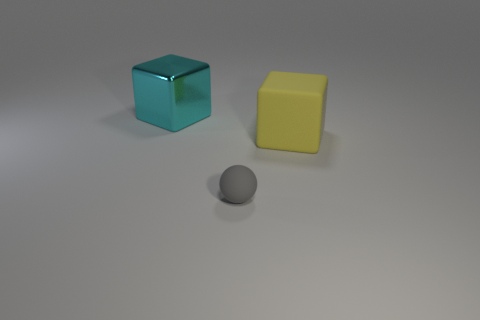Add 2 yellow rubber objects. How many objects exist? 5 Subtract 1 gray spheres. How many objects are left? 2 Subtract all spheres. How many objects are left? 2 Subtract all brown cubes. Subtract all gray cylinders. How many cubes are left? 2 Subtract all big rubber blocks. Subtract all metallic things. How many objects are left? 1 Add 1 shiny blocks. How many shiny blocks are left? 2 Add 2 tiny yellow balls. How many tiny yellow balls exist? 2 